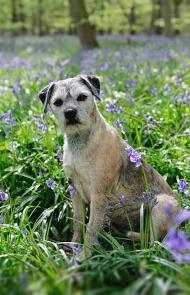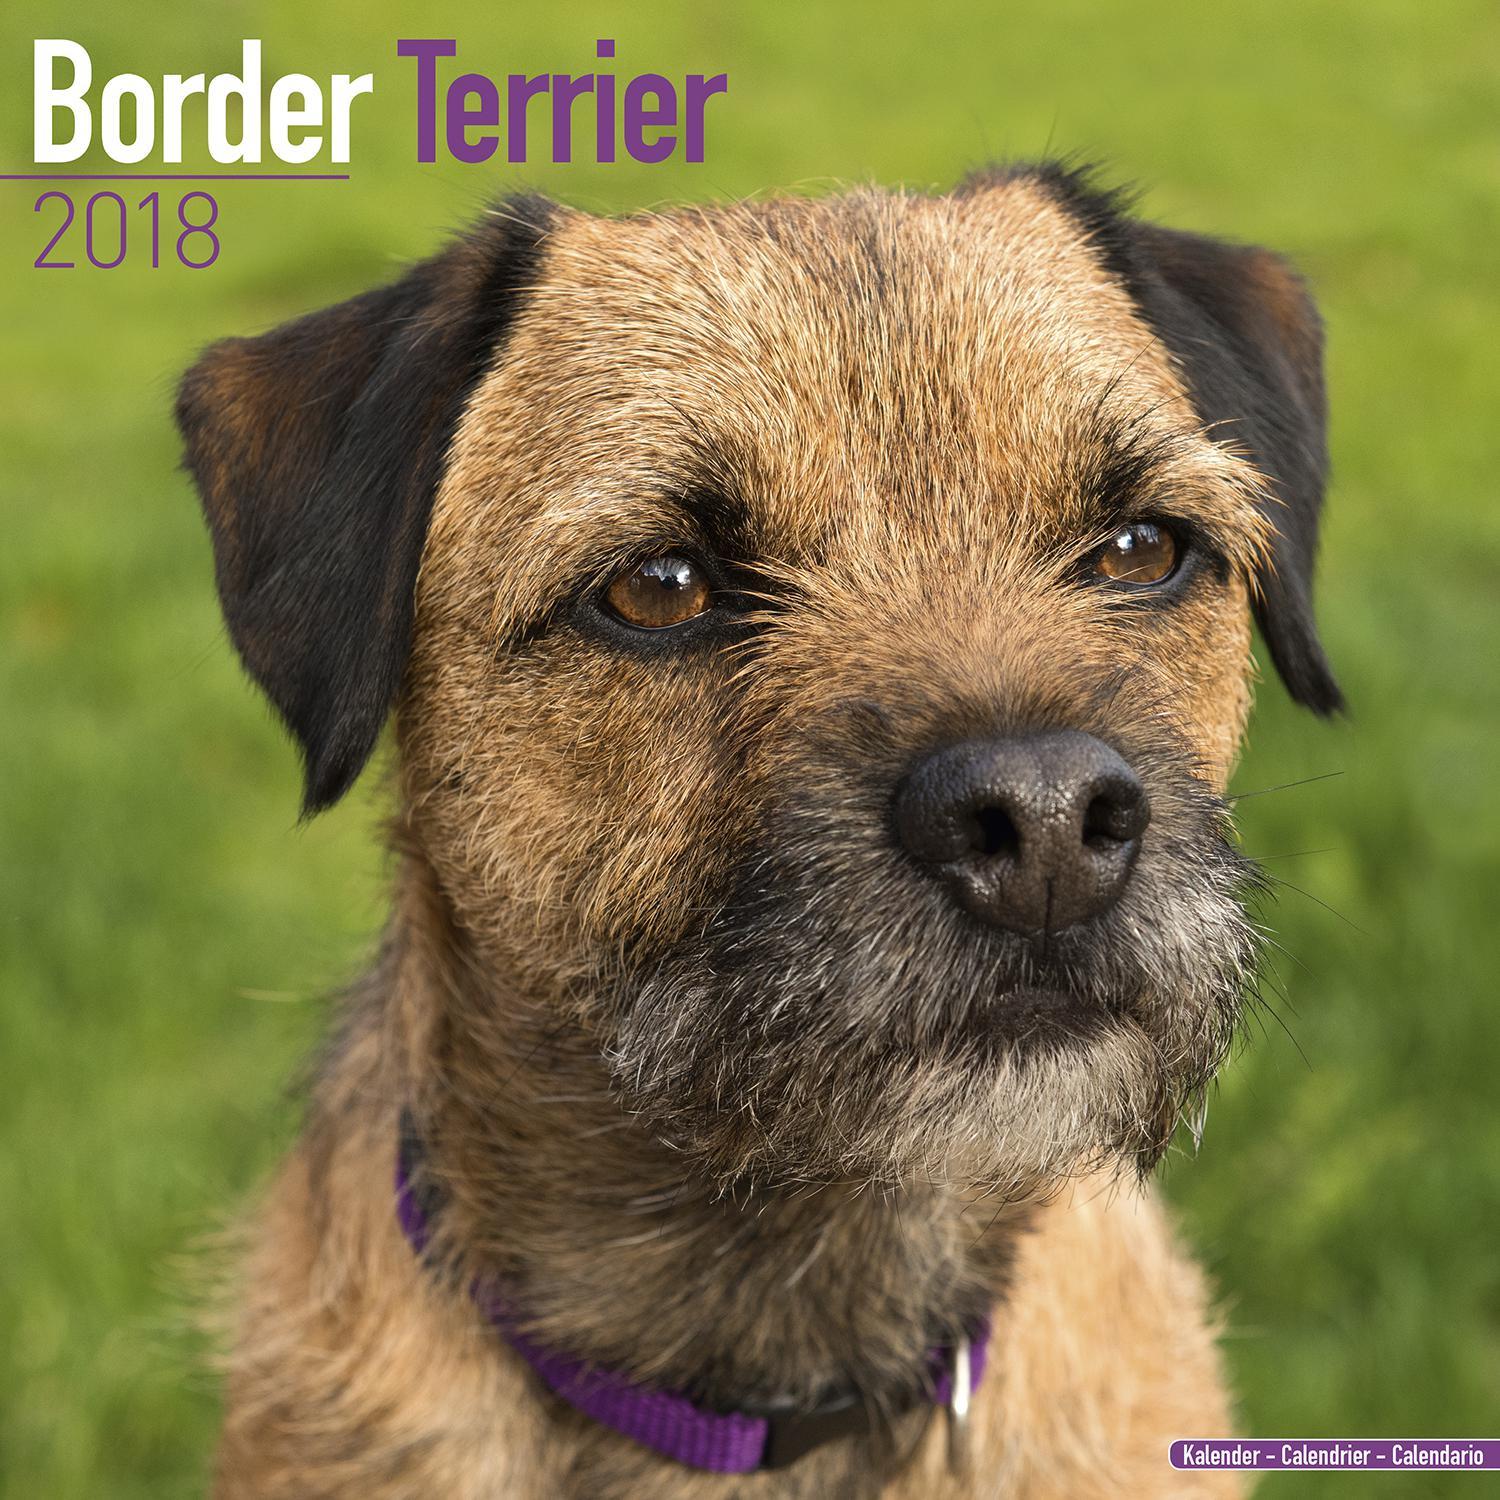The first image is the image on the left, the second image is the image on the right. For the images displayed, is the sentence "The left and right image contains the same number of dogs with one running on grass." factually correct? Answer yes or no. No. The first image is the image on the left, the second image is the image on the right. For the images shown, is this caption "The left image shows a dog sitting with all paws on the grass." true? Answer yes or no. Yes. 